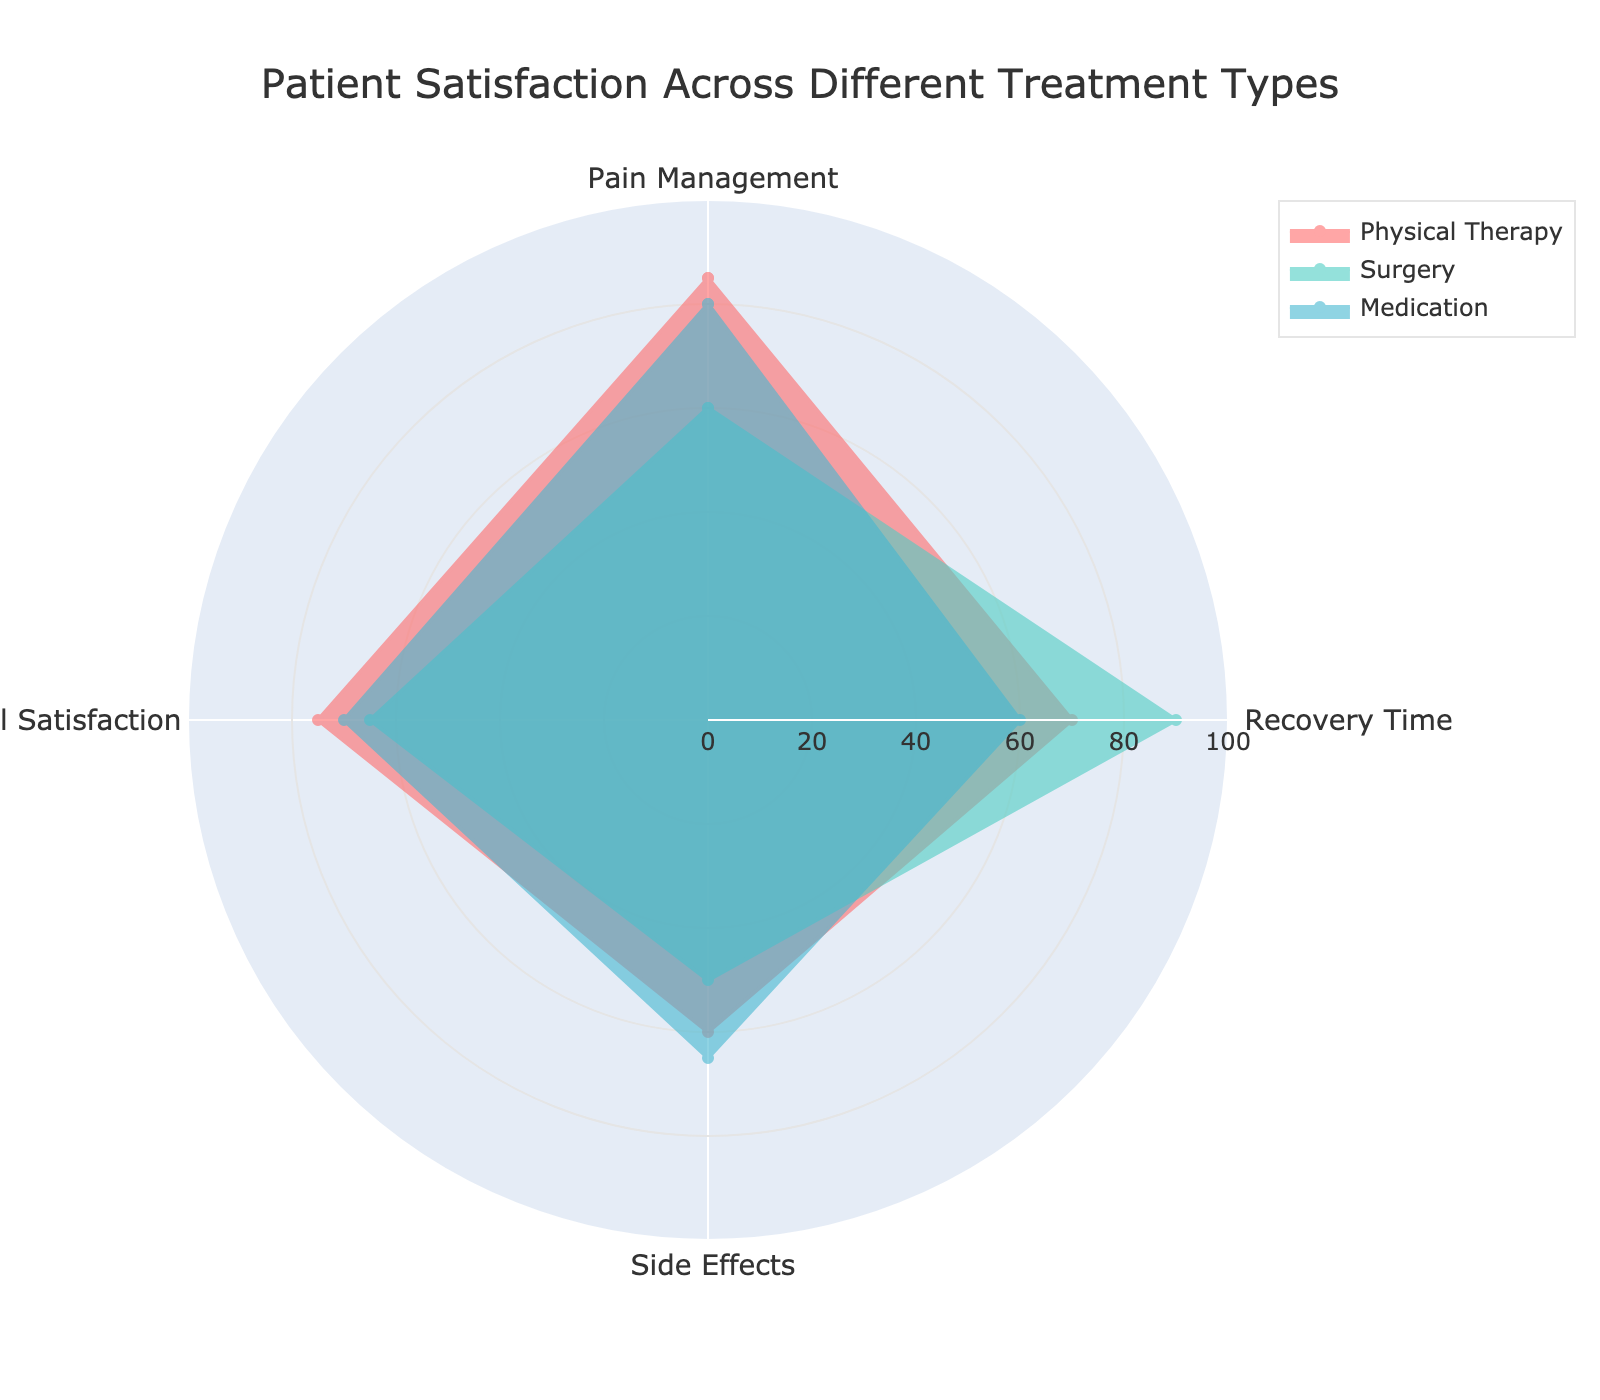What's the average Overall Satisfaction across all treatment types? Calculate the Overall Satisfaction for each treatment type: Physical Therapy (75), Surgery (65), Medication (70). Sum them up: 75 + 65 + 70 = 210. Divide by the number of treatment types (3): 210 / 3 = 70
Answer: 70 Which treatment type has the highest score in Pain Management? Check the Pain Management scores for each treatment type: Physical Therapy (85), Surgery (60), Medication (80). The highest score is 85 for Physical Therapy
Answer: Physical Therapy Between Physical Therapy and Surgery, which treatment type has a lower Side Effects score? Evaluate the Side Effects scores for Physical Therapy (60) and Surgery (50). Surgery has the lower score
Answer: Surgery Is the average Recovery Time score of Physical Therapy and Medication higher than the Surgery score alone? Calculate the Recovery Time scores of Physical Therapy (70) and Medication (60). Average = (70 + 60) / 2 = 65. Compare with Surgery's Recovery Time score (90). Surgery's score is higher
Answer: No What is the disparity in Overall Satisfaction between the highest and lowest scoring treatment types? Check the Overall Satisfaction scores: Physical Therapy (75), Surgery (65), Medication (70). The highest is 75 (Physical Therapy) and the lowest is 65 (Surgery). The disparity is 75 - 65 = 10
Answer: 10 Which treatment type has the most balanced scores across all evaluation criteria? Observe the radar chart's coverage area for each treatment type. Checking scores roughly: 
- Physical Therapy (85, 70, 60, 75): range 60-85, smaller variations.
- Surgery (60, 90, 50, 65): range 50-90, larger variations.
- Medication (80, 60, 65, 70): range 60-80, moderate variations.
Physical Therapy appears the most balanced
Answer: Physical Therapy 